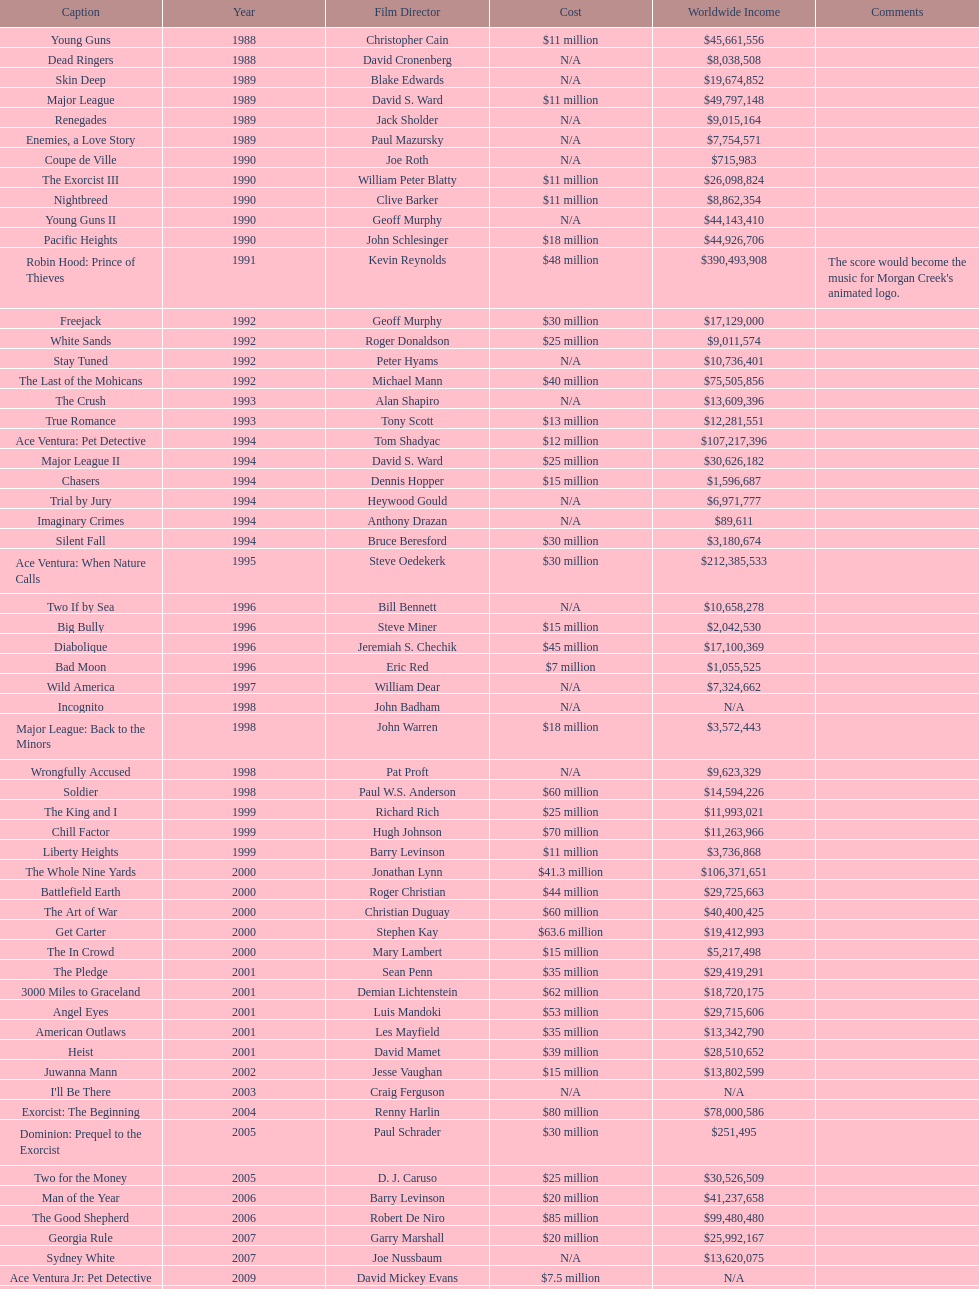What is the top grossing film? Robin Hood: Prince of Thieves. 